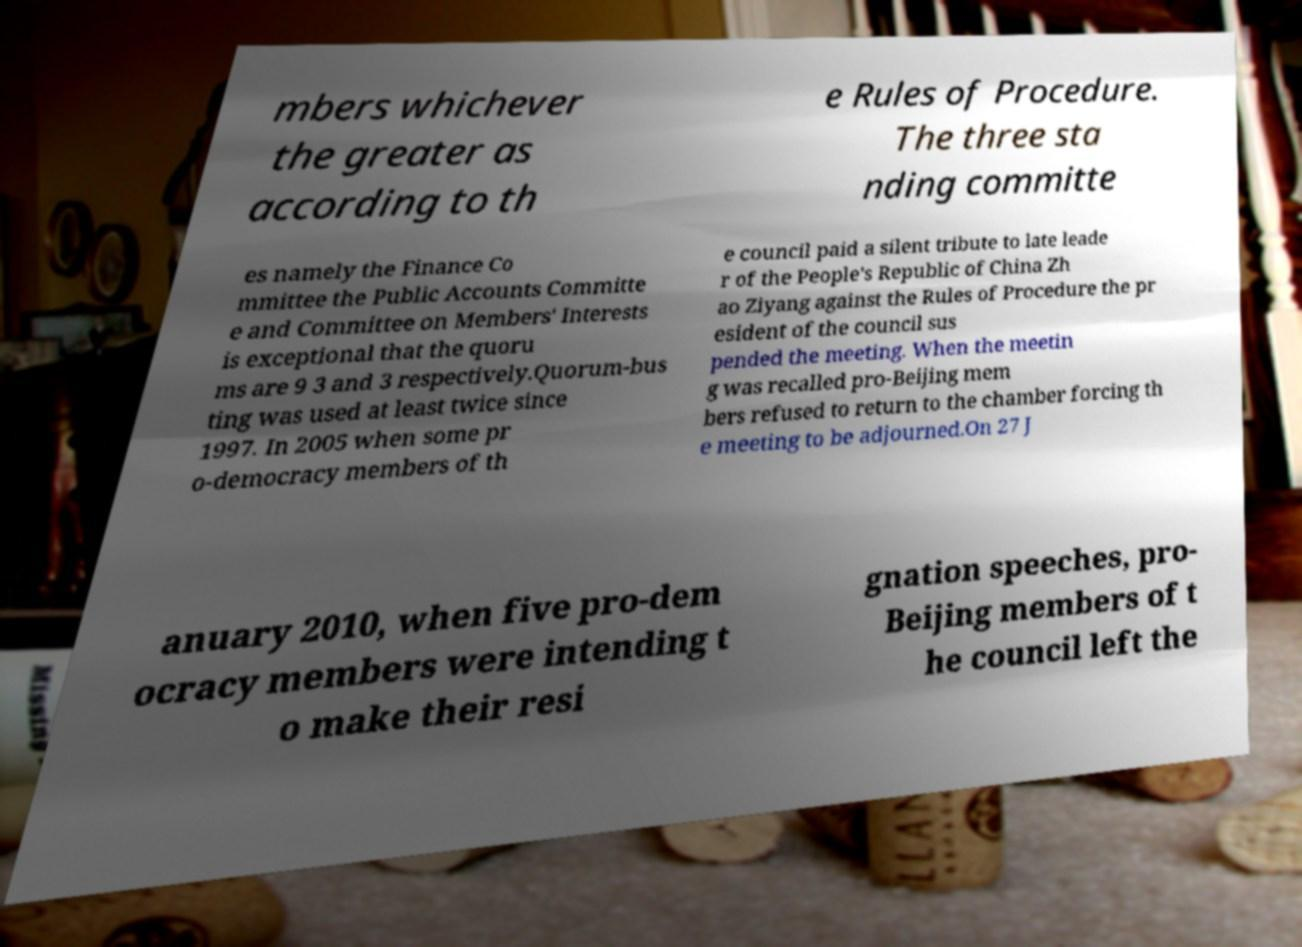There's text embedded in this image that I need extracted. Can you transcribe it verbatim? mbers whichever the greater as according to th e Rules of Procedure. The three sta nding committe es namely the Finance Co mmittee the Public Accounts Committe e and Committee on Members' Interests is exceptional that the quoru ms are 9 3 and 3 respectively.Quorum-bus ting was used at least twice since 1997. In 2005 when some pr o-democracy members of th e council paid a silent tribute to late leade r of the People's Republic of China Zh ao Ziyang against the Rules of Procedure the pr esident of the council sus pended the meeting. When the meetin g was recalled pro-Beijing mem bers refused to return to the chamber forcing th e meeting to be adjourned.On 27 J anuary 2010, when five pro-dem ocracy members were intending t o make their resi gnation speeches, pro- Beijing members of t he council left the 